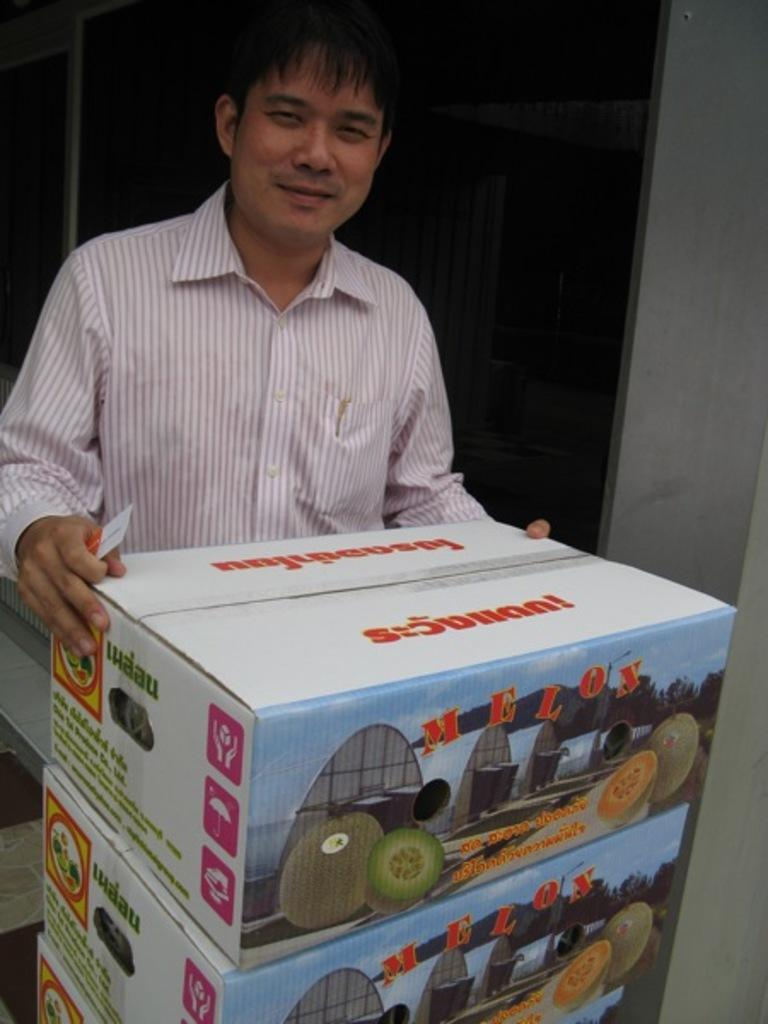<image>
Offer a succinct explanation of the picture presented. man in striped shirt stacking boxes of melos 